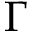<formula> <loc_0><loc_0><loc_500><loc_500>\Gamma</formula> 